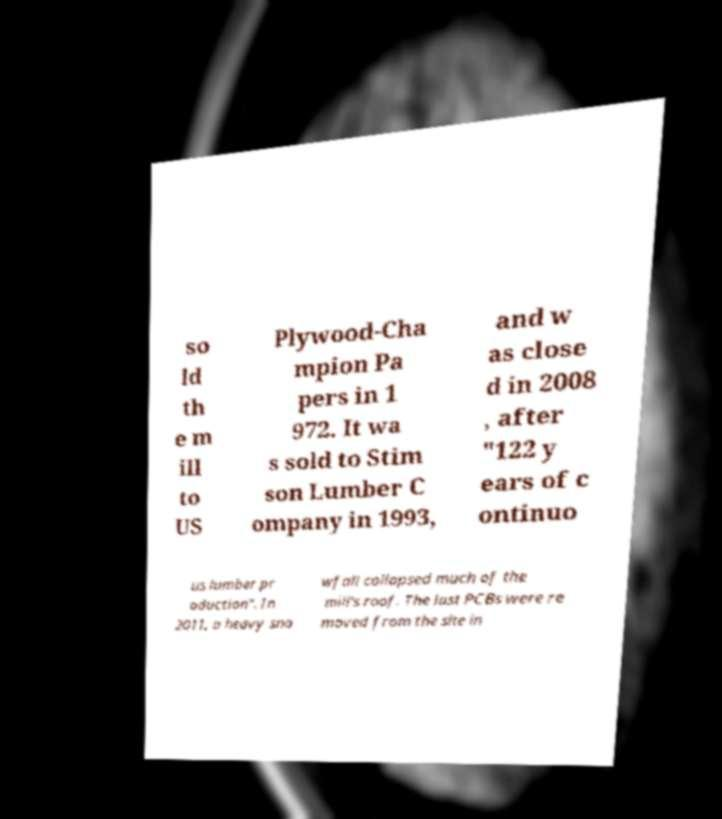What messages or text are displayed in this image? I need them in a readable, typed format. so ld th e m ill to US Plywood-Cha mpion Pa pers in 1 972. It wa s sold to Stim son Lumber C ompany in 1993, and w as close d in 2008 , after "122 y ears of c ontinuo us lumber pr oduction". In 2011, a heavy sno wfall collapsed much of the mill's roof. The last PCBs were re moved from the site in 